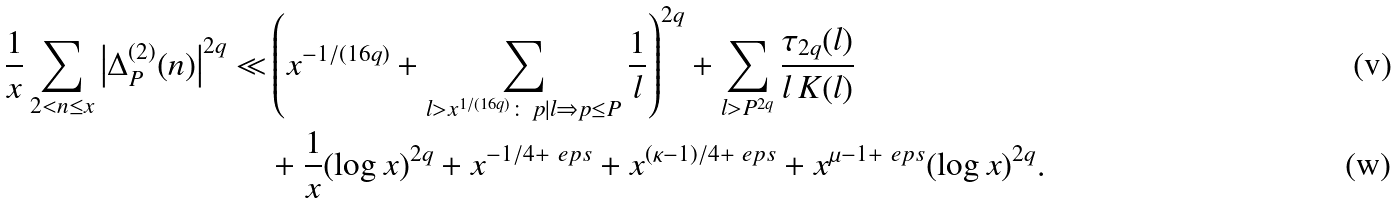Convert formula to latex. <formula><loc_0><loc_0><loc_500><loc_500>\frac { 1 } { x } \sum _ { 2 < n \leq x } \left | \Delta _ { P } ^ { ( 2 ) } ( n ) \right | ^ { 2 q } \ll & \left ( x ^ { - 1 / ( 1 6 q ) } + \sum _ { l > x ^ { 1 / ( 1 6 q ) } \colon \, p | l \Rightarrow p \leq P } \frac { 1 } { l } \right ) ^ { 2 q } + \sum _ { l > P ^ { 2 q } } \frac { \tau _ { 2 q } ( l ) } { l \, K ( l ) } \\ & + \frac { 1 } { x } ( \log x ) ^ { 2 q } + x ^ { - 1 / 4 + \ e p s } + x ^ { ( \kappa - 1 ) / 4 + \ e p s } + x ^ { \mu - 1 + \ e p s } ( \log x ) ^ { 2 q } .</formula> 